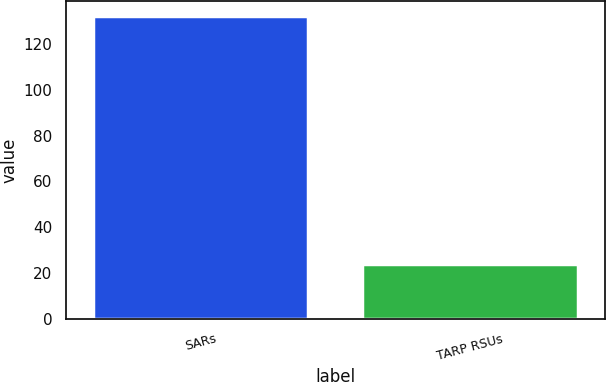Convert chart. <chart><loc_0><loc_0><loc_500><loc_500><bar_chart><fcel>SARs<fcel>TARP RSUs<nl><fcel>132<fcel>24<nl></chart> 